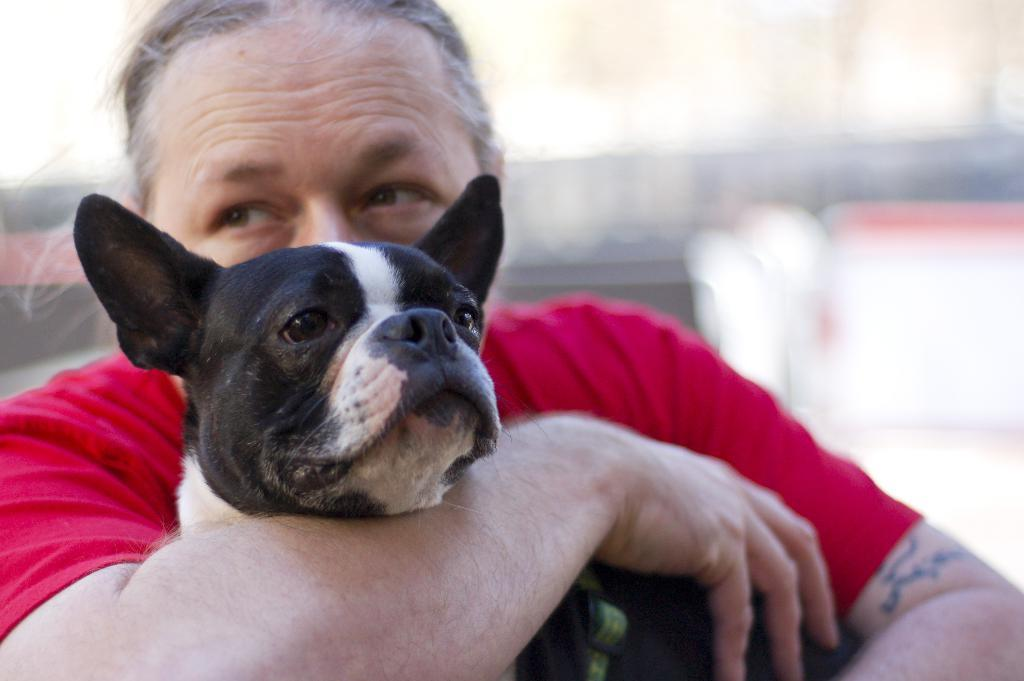What is the main subject of the image? There is a person in the image. What is the person doing in the image? The person is holding a puppy dog. What is the annual income of the person in the image? There is no information about the person's income in the image. 